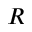Convert formula to latex. <formula><loc_0><loc_0><loc_500><loc_500>R</formula> 